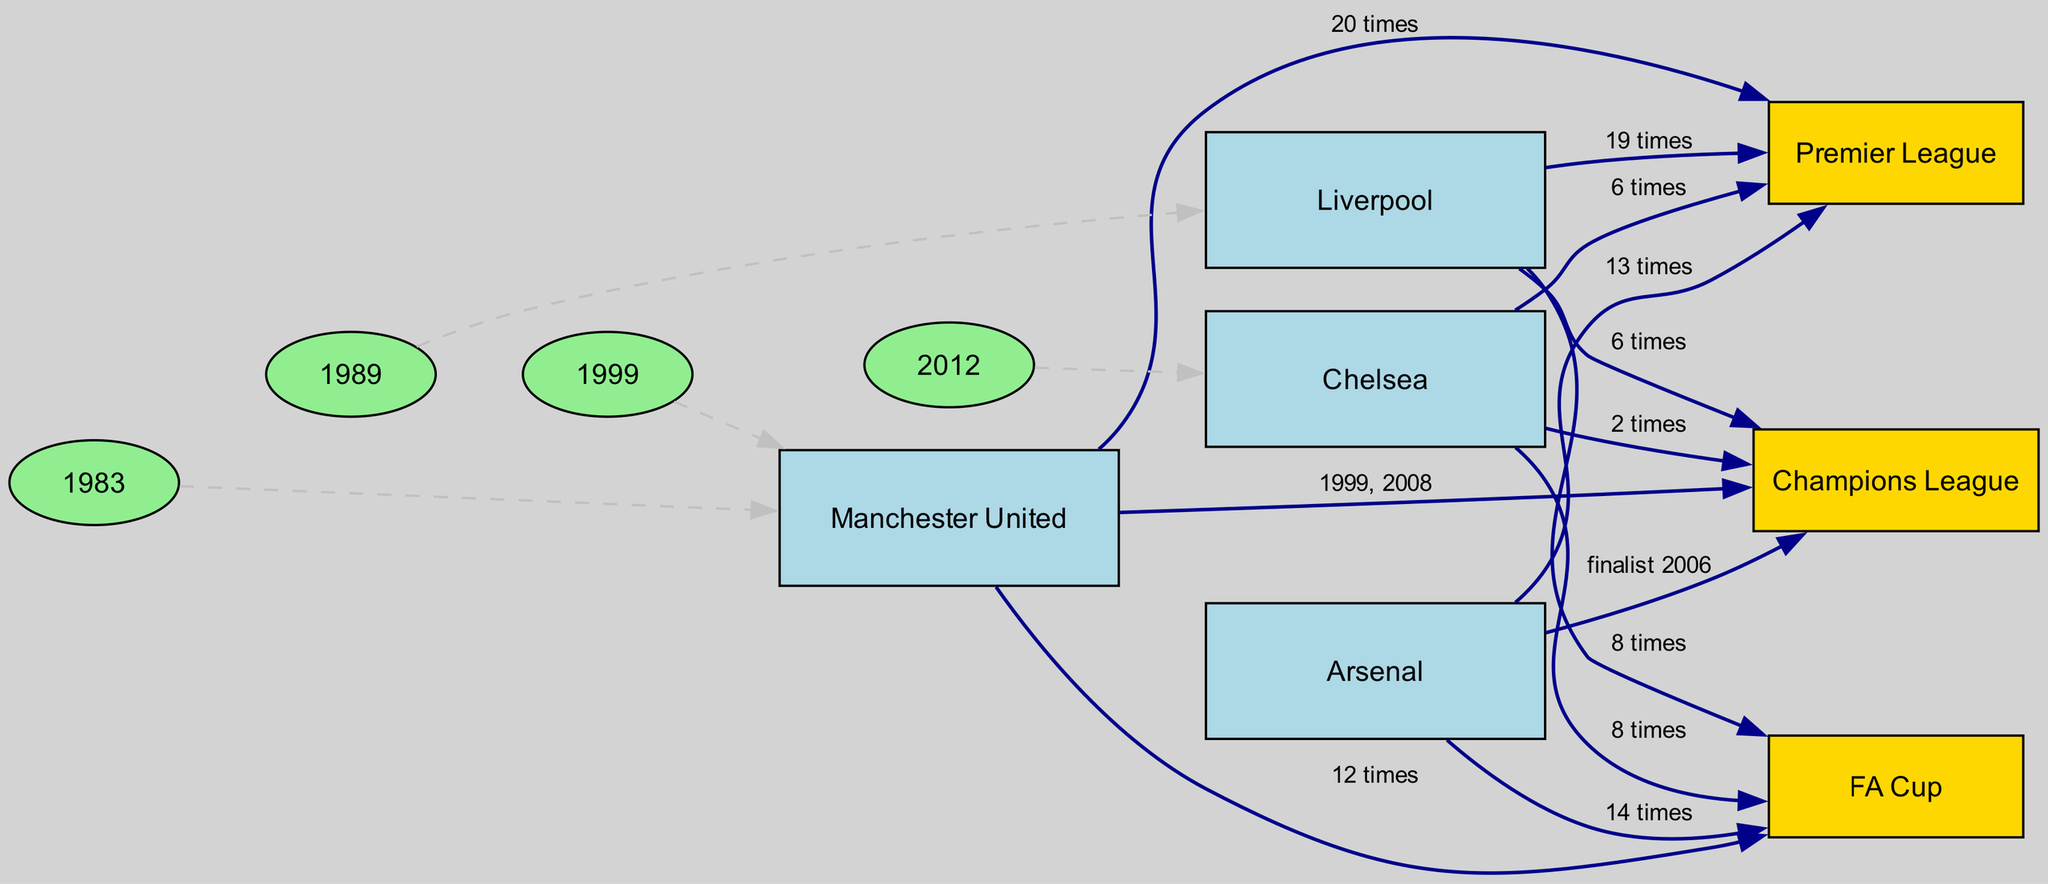What trophies has Manchester United won the most? From the diagram, we look at the edges connected to Manchester United. The highest trophy count connected is the Premier League with "20 times". This is the maximum trophy count displayed for Manchester United.
Answer: Premier League How many times has Liverpool won the Champions League? Examining the edge from Liverpool to the Champions League, it shows "6 times". This is a direct connection and the exact number given in the diagram for Liverpool's Champions League wins.
Answer: 6 times What year did Chelsea win their first Champions League? The diagram does not specify the year Chelsea won their Champions League. However, it does state '2012' connects to Chelsea, indicating that was when they won it. Thus, we can conclude that 2012 corresponds with their Champions League win.
Answer: 2012 Which club has won the FA Cup the most times? Looking at the edges from all clubs to the FA Cup, Arsenal is connected with "14 times". This is the highest trophy count shown for the FA Cup among the clubs, making Arsenal the club with the most wins.
Answer: Arsenal In what year did Manchester United last win the FA Cup? The edge leading from Manchester United to the FA Cup states "12 times" in 2023. While it does not specify the exact year of the last win, the year 2023 indicates it is the most recent trophy count available in the diagram for the FA Cup. Hence, we deduce that it is the latest win.
Answer: 2023 Which club is linked to 1983 in the diagram? By scanning the diagram, the edge from "1983" leads to Manchester United, suggesting a notable connection. Although it might not clarify the exact nature of the connection, this close relationship indicates something historical occurred with Manchester United in that year.
Answer: Manchester United How many major domestic trophies has Chelsea won in total? Counting the edges for Chelsea, they have won "8 times" for the FA Cup and "6 times" for the Premier League, and "2 times" for the Champions League. Adding these figures gives 16 total major domestic trophies Chelsea has won.
Answer: 16 times Which club has the fewest Premier League trophies? From the diagram, Chelsea (6 times) and Liverpool (19 times) have fewer compared to Manchester United (20 times), and Arsenal (13 times). Thus, Chelsea holds the least Premier League wins among the listed clubs.
Answer: Chelsea 